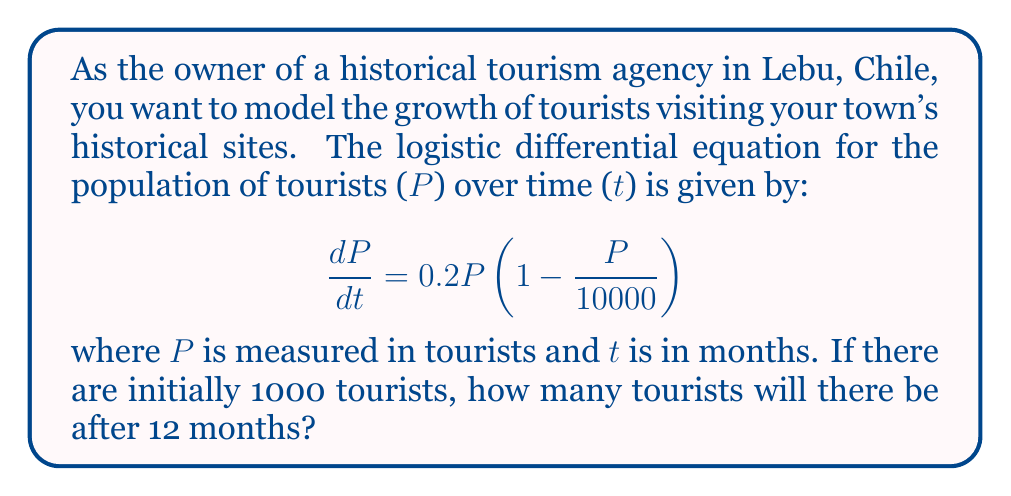Can you solve this math problem? To solve this logistic differential equation, we'll follow these steps:

1) The general solution to the logistic differential equation is:

   $$P(t) = \frac{K}{1 + Ce^{-rt}}$$

   where K is the carrying capacity, r is the growth rate, and C is a constant.

2) From the given equation, we can identify:
   K = 10000 (carrying capacity)
   r = 0.2 (growth rate)

3) To find C, we use the initial condition P(0) = 1000:

   $$1000 = \frac{10000}{1 + C}$$

   $$C = 9$$

4) Now our specific solution is:

   $$P(t) = \frac{10000}{1 + 9e^{-0.2t}}$$

5) To find P(12), we substitute t = 12:

   $$P(12) = \frac{10000}{1 + 9e^{-0.2(12)}}$$

6) Simplify:
   $$P(12) = \frac{10000}{1 + 9e^{-2.4}}$$
   $$P(12) = \frac{10000}{1 + 9(0.0907)}$$
   $$P(12) = \frac{10000}{1.8163}$$
   $$P(12) = 5506.25$$

7) Since we're dealing with whole tourists, we round to the nearest integer.
Answer: 5506 tourists 